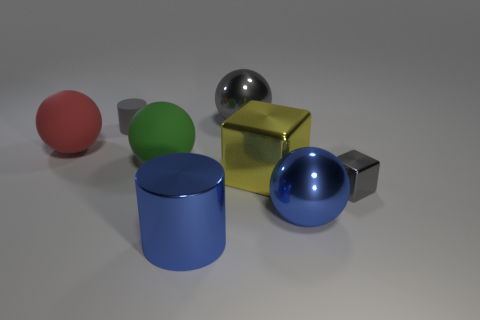What number of other things are made of the same material as the blue cylinder? There are four objects in the image that appear to be made from the same glossy material as the blue cylinder. This assessment considers visual similarities such as reflection and surface texture. 